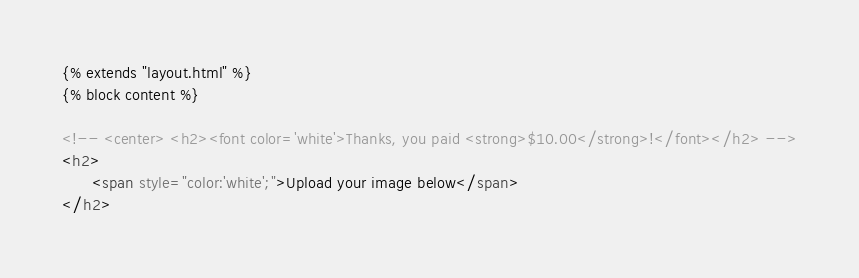<code> <loc_0><loc_0><loc_500><loc_500><_HTML_>{% extends "layout.html" %}
{% block content %}

<!-- <center> <h2><font color='white'>Thanks, you paid <strong>$10.00</strong>!</font></h2> -->
<h2>
      <span style="color:'white';">Upload your image below</span>
</h2></code> 